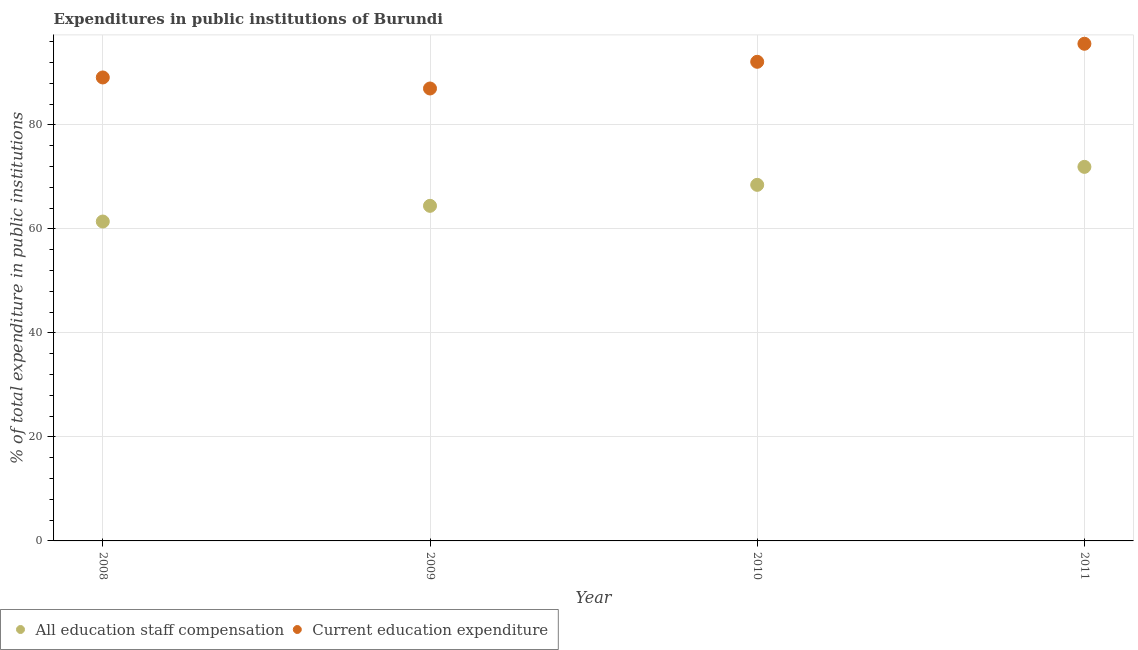How many different coloured dotlines are there?
Offer a very short reply. 2. Is the number of dotlines equal to the number of legend labels?
Keep it short and to the point. Yes. What is the expenditure in education in 2010?
Offer a very short reply. 92.14. Across all years, what is the maximum expenditure in staff compensation?
Ensure brevity in your answer.  71.94. Across all years, what is the minimum expenditure in staff compensation?
Give a very brief answer. 61.43. What is the total expenditure in education in the graph?
Provide a succinct answer. 363.89. What is the difference between the expenditure in staff compensation in 2008 and that in 2010?
Your answer should be very brief. -7.05. What is the difference between the expenditure in staff compensation in 2010 and the expenditure in education in 2009?
Keep it short and to the point. -18.53. What is the average expenditure in education per year?
Ensure brevity in your answer.  90.97. In the year 2008, what is the difference between the expenditure in staff compensation and expenditure in education?
Your answer should be compact. -27.7. What is the ratio of the expenditure in education in 2008 to that in 2010?
Your response must be concise. 0.97. What is the difference between the highest and the second highest expenditure in education?
Give a very brief answer. 3.47. What is the difference between the highest and the lowest expenditure in staff compensation?
Your answer should be compact. 10.51. In how many years, is the expenditure in education greater than the average expenditure in education taken over all years?
Make the answer very short. 2. Does the expenditure in education monotonically increase over the years?
Provide a succinct answer. No. How many dotlines are there?
Make the answer very short. 2. What is the difference between two consecutive major ticks on the Y-axis?
Offer a terse response. 20. Does the graph contain any zero values?
Provide a succinct answer. No. Does the graph contain grids?
Ensure brevity in your answer.  Yes. What is the title of the graph?
Your answer should be very brief. Expenditures in public institutions of Burundi. Does "Central government" appear as one of the legend labels in the graph?
Your answer should be very brief. No. What is the label or title of the X-axis?
Your response must be concise. Year. What is the label or title of the Y-axis?
Make the answer very short. % of total expenditure in public institutions. What is the % of total expenditure in public institutions in All education staff compensation in 2008?
Your answer should be very brief. 61.43. What is the % of total expenditure in public institutions of Current education expenditure in 2008?
Offer a very short reply. 89.13. What is the % of total expenditure in public institutions in All education staff compensation in 2009?
Ensure brevity in your answer.  64.44. What is the % of total expenditure in public institutions of Current education expenditure in 2009?
Make the answer very short. 87.01. What is the % of total expenditure in public institutions in All education staff compensation in 2010?
Your answer should be compact. 68.48. What is the % of total expenditure in public institutions in Current education expenditure in 2010?
Your answer should be very brief. 92.14. What is the % of total expenditure in public institutions of All education staff compensation in 2011?
Provide a short and direct response. 71.94. What is the % of total expenditure in public institutions of Current education expenditure in 2011?
Your response must be concise. 95.61. Across all years, what is the maximum % of total expenditure in public institutions in All education staff compensation?
Offer a very short reply. 71.94. Across all years, what is the maximum % of total expenditure in public institutions in Current education expenditure?
Ensure brevity in your answer.  95.61. Across all years, what is the minimum % of total expenditure in public institutions of All education staff compensation?
Your answer should be compact. 61.43. Across all years, what is the minimum % of total expenditure in public institutions in Current education expenditure?
Offer a terse response. 87.01. What is the total % of total expenditure in public institutions of All education staff compensation in the graph?
Ensure brevity in your answer.  266.28. What is the total % of total expenditure in public institutions of Current education expenditure in the graph?
Provide a succinct answer. 363.89. What is the difference between the % of total expenditure in public institutions of All education staff compensation in 2008 and that in 2009?
Ensure brevity in your answer.  -3.02. What is the difference between the % of total expenditure in public institutions of Current education expenditure in 2008 and that in 2009?
Your answer should be very brief. 2.12. What is the difference between the % of total expenditure in public institutions of All education staff compensation in 2008 and that in 2010?
Offer a terse response. -7.05. What is the difference between the % of total expenditure in public institutions of Current education expenditure in 2008 and that in 2010?
Provide a succinct answer. -3.01. What is the difference between the % of total expenditure in public institutions of All education staff compensation in 2008 and that in 2011?
Your response must be concise. -10.51. What is the difference between the % of total expenditure in public institutions of Current education expenditure in 2008 and that in 2011?
Offer a terse response. -6.48. What is the difference between the % of total expenditure in public institutions of All education staff compensation in 2009 and that in 2010?
Ensure brevity in your answer.  -4.04. What is the difference between the % of total expenditure in public institutions in Current education expenditure in 2009 and that in 2010?
Offer a terse response. -5.13. What is the difference between the % of total expenditure in public institutions in All education staff compensation in 2009 and that in 2011?
Give a very brief answer. -7.49. What is the difference between the % of total expenditure in public institutions of Current education expenditure in 2009 and that in 2011?
Your answer should be very brief. -8.6. What is the difference between the % of total expenditure in public institutions in All education staff compensation in 2010 and that in 2011?
Make the answer very short. -3.46. What is the difference between the % of total expenditure in public institutions in Current education expenditure in 2010 and that in 2011?
Make the answer very short. -3.47. What is the difference between the % of total expenditure in public institutions in All education staff compensation in 2008 and the % of total expenditure in public institutions in Current education expenditure in 2009?
Your answer should be very brief. -25.58. What is the difference between the % of total expenditure in public institutions in All education staff compensation in 2008 and the % of total expenditure in public institutions in Current education expenditure in 2010?
Your answer should be very brief. -30.72. What is the difference between the % of total expenditure in public institutions in All education staff compensation in 2008 and the % of total expenditure in public institutions in Current education expenditure in 2011?
Your response must be concise. -34.19. What is the difference between the % of total expenditure in public institutions in All education staff compensation in 2009 and the % of total expenditure in public institutions in Current education expenditure in 2010?
Make the answer very short. -27.7. What is the difference between the % of total expenditure in public institutions in All education staff compensation in 2009 and the % of total expenditure in public institutions in Current education expenditure in 2011?
Keep it short and to the point. -31.17. What is the difference between the % of total expenditure in public institutions of All education staff compensation in 2010 and the % of total expenditure in public institutions of Current education expenditure in 2011?
Make the answer very short. -27.13. What is the average % of total expenditure in public institutions in All education staff compensation per year?
Offer a terse response. 66.57. What is the average % of total expenditure in public institutions of Current education expenditure per year?
Keep it short and to the point. 90.97. In the year 2008, what is the difference between the % of total expenditure in public institutions in All education staff compensation and % of total expenditure in public institutions in Current education expenditure?
Give a very brief answer. -27.7. In the year 2009, what is the difference between the % of total expenditure in public institutions in All education staff compensation and % of total expenditure in public institutions in Current education expenditure?
Your answer should be compact. -22.57. In the year 2010, what is the difference between the % of total expenditure in public institutions of All education staff compensation and % of total expenditure in public institutions of Current education expenditure?
Give a very brief answer. -23.66. In the year 2011, what is the difference between the % of total expenditure in public institutions of All education staff compensation and % of total expenditure in public institutions of Current education expenditure?
Your answer should be very brief. -23.68. What is the ratio of the % of total expenditure in public institutions of All education staff compensation in 2008 to that in 2009?
Provide a succinct answer. 0.95. What is the ratio of the % of total expenditure in public institutions in Current education expenditure in 2008 to that in 2009?
Your answer should be compact. 1.02. What is the ratio of the % of total expenditure in public institutions in All education staff compensation in 2008 to that in 2010?
Provide a succinct answer. 0.9. What is the ratio of the % of total expenditure in public institutions of Current education expenditure in 2008 to that in 2010?
Make the answer very short. 0.97. What is the ratio of the % of total expenditure in public institutions in All education staff compensation in 2008 to that in 2011?
Give a very brief answer. 0.85. What is the ratio of the % of total expenditure in public institutions in Current education expenditure in 2008 to that in 2011?
Make the answer very short. 0.93. What is the ratio of the % of total expenditure in public institutions in All education staff compensation in 2009 to that in 2010?
Ensure brevity in your answer.  0.94. What is the ratio of the % of total expenditure in public institutions in Current education expenditure in 2009 to that in 2010?
Make the answer very short. 0.94. What is the ratio of the % of total expenditure in public institutions of All education staff compensation in 2009 to that in 2011?
Provide a short and direct response. 0.9. What is the ratio of the % of total expenditure in public institutions of Current education expenditure in 2009 to that in 2011?
Your answer should be compact. 0.91. What is the ratio of the % of total expenditure in public institutions in All education staff compensation in 2010 to that in 2011?
Provide a short and direct response. 0.95. What is the ratio of the % of total expenditure in public institutions of Current education expenditure in 2010 to that in 2011?
Offer a very short reply. 0.96. What is the difference between the highest and the second highest % of total expenditure in public institutions of All education staff compensation?
Provide a succinct answer. 3.46. What is the difference between the highest and the second highest % of total expenditure in public institutions of Current education expenditure?
Offer a very short reply. 3.47. What is the difference between the highest and the lowest % of total expenditure in public institutions in All education staff compensation?
Make the answer very short. 10.51. What is the difference between the highest and the lowest % of total expenditure in public institutions of Current education expenditure?
Your answer should be compact. 8.6. 